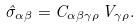<formula> <loc_0><loc_0><loc_500><loc_500>\hat { \sigma } _ { \alpha \beta } = C _ { \alpha \beta \gamma \rho } \, V _ { \gamma \rho } .</formula> 